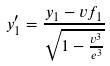<formula> <loc_0><loc_0><loc_500><loc_500>y _ { 1 } ^ { \prime } = \frac { y _ { 1 } - v f _ { 1 } } { \sqrt { 1 - \frac { v ^ { 3 } } { e ^ { 3 } } } }</formula> 